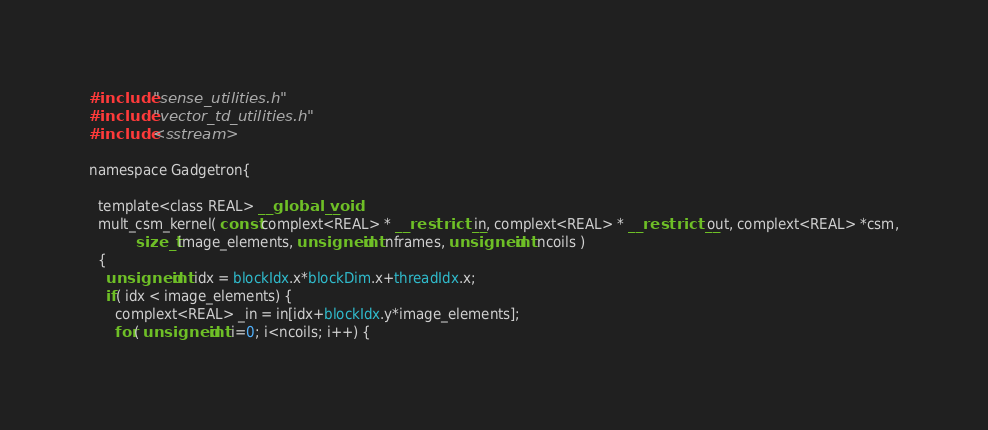Convert code to text. <code><loc_0><loc_0><loc_500><loc_500><_Cuda_>#include "sense_utilities.h"
#include "vector_td_utilities.h"
#include <sstream>

namespace Gadgetron{

  template<class REAL> __global__ void 
  mult_csm_kernel( const complext<REAL> * __restrict__ in, complext<REAL> * __restrict__ out, complext<REAL> *csm,
		   size_t image_elements, unsigned int nframes, unsigned int ncoils )
  {
    unsigned int idx = blockIdx.x*blockDim.x+threadIdx.x;
    if( idx < image_elements) {
      complext<REAL> _in = in[idx+blockIdx.y*image_elements];
      for( unsigned int i=0; i<ncoils; i++) {</code> 